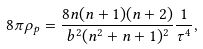<formula> <loc_0><loc_0><loc_500><loc_500>8 \pi \rho _ { p } = \frac { 8 n ( n + 1 ) ( n + 2 ) } { b ^ { 2 } ( n ^ { 2 } + n + 1 ) ^ { 2 } } \frac { 1 } { \tau ^ { 4 } } ,</formula> 